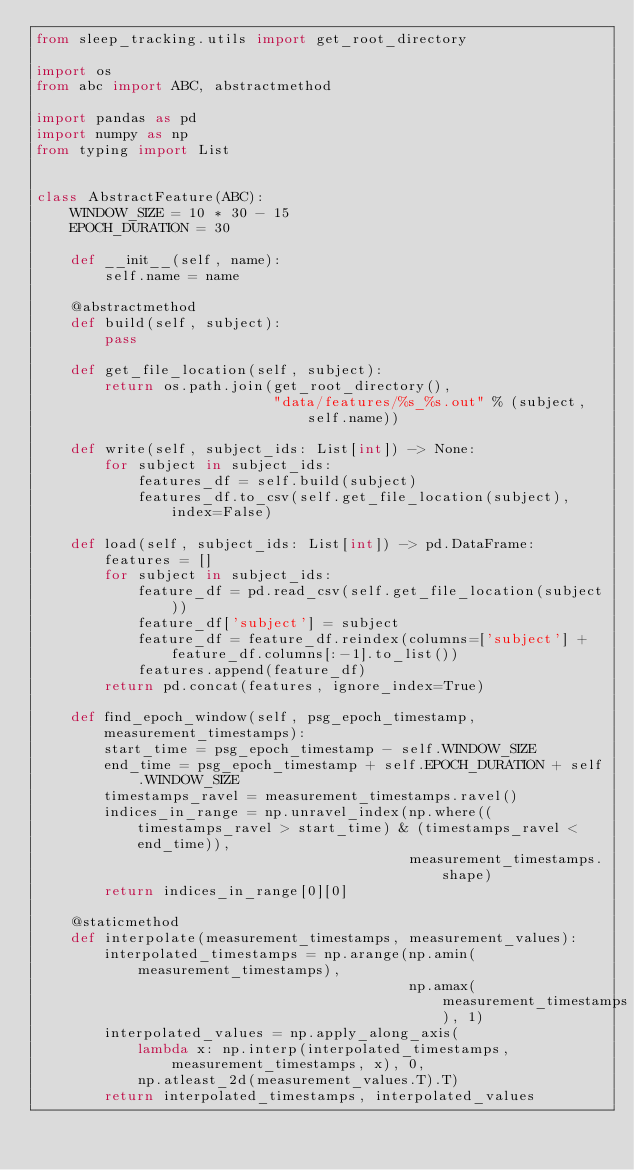<code> <loc_0><loc_0><loc_500><loc_500><_Python_>from sleep_tracking.utils import get_root_directory

import os
from abc import ABC, abstractmethod

import pandas as pd
import numpy as np
from typing import List


class AbstractFeature(ABC):
    WINDOW_SIZE = 10 * 30 - 15
    EPOCH_DURATION = 30

    def __init__(self, name):
        self.name = name

    @abstractmethod
    def build(self, subject):
        pass

    def get_file_location(self, subject):
        return os.path.join(get_root_directory(),
                            "data/features/%s_%s.out" % (subject, self.name))

    def write(self, subject_ids: List[int]) -> None:
        for subject in subject_ids:
            features_df = self.build(subject)
            features_df.to_csv(self.get_file_location(subject), index=False)

    def load(self, subject_ids: List[int]) -> pd.DataFrame:
        features = []
        for subject in subject_ids:
            feature_df = pd.read_csv(self.get_file_location(subject))
            feature_df['subject'] = subject
            feature_df = feature_df.reindex(columns=['subject'] + feature_df.columns[:-1].to_list())
            features.append(feature_df)
        return pd.concat(features, ignore_index=True)

    def find_epoch_window(self, psg_epoch_timestamp, measurement_timestamps):
        start_time = psg_epoch_timestamp - self.WINDOW_SIZE
        end_time = psg_epoch_timestamp + self.EPOCH_DURATION + self.WINDOW_SIZE
        timestamps_ravel = measurement_timestamps.ravel()
        indices_in_range = np.unravel_index(np.where((timestamps_ravel > start_time) & (timestamps_ravel < end_time)),
                                            measurement_timestamps.shape)
        return indices_in_range[0][0]

    @staticmethod
    def interpolate(measurement_timestamps, measurement_values):
        interpolated_timestamps = np.arange(np.amin(measurement_timestamps),
                                            np.amax(measurement_timestamps), 1)
        interpolated_values = np.apply_along_axis(
            lambda x: np.interp(interpolated_timestamps, measurement_timestamps, x), 0,
            np.atleast_2d(measurement_values.T).T)
        return interpolated_timestamps, interpolated_values
</code> 